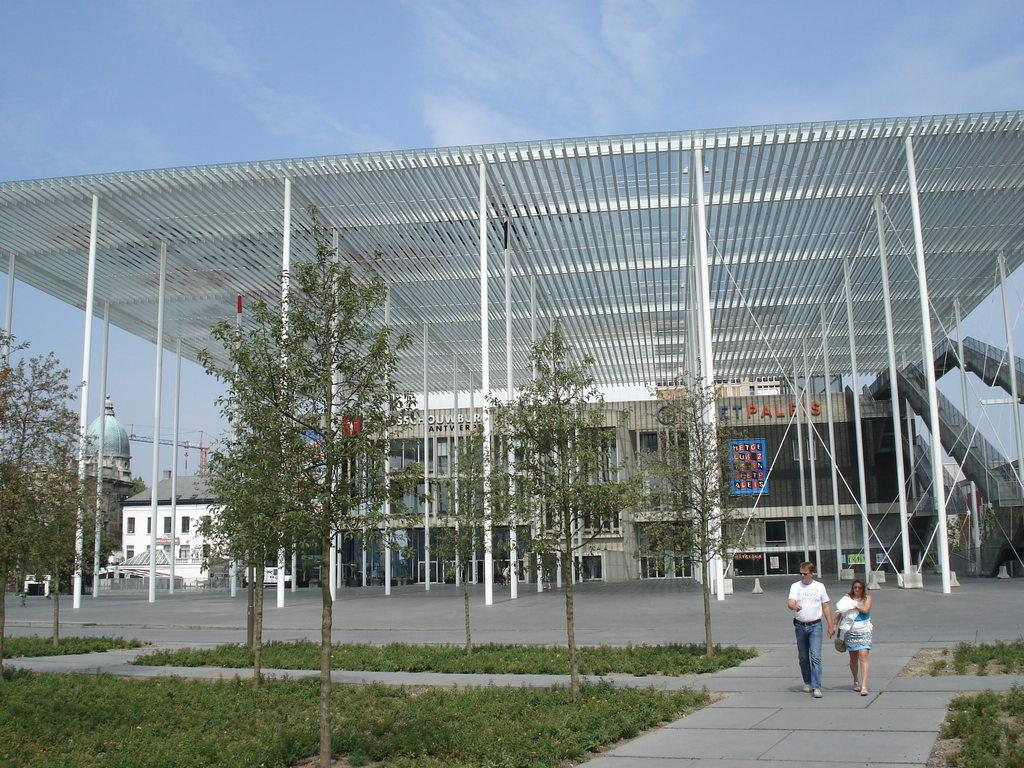How many people are in the image? There are two people in the image. What are the people doing in the image? The people are walking on a platform. What type of vegetation can be seen in the image? There is grass and trees in the image. What architectural features are present in the image? There are pillars and buildings in the image. What type of lizards can be seen climbing the buildings in the image? There are no lizards present in the image; it only features people walking on a platform, grass, trees, pillars, and buildings. 